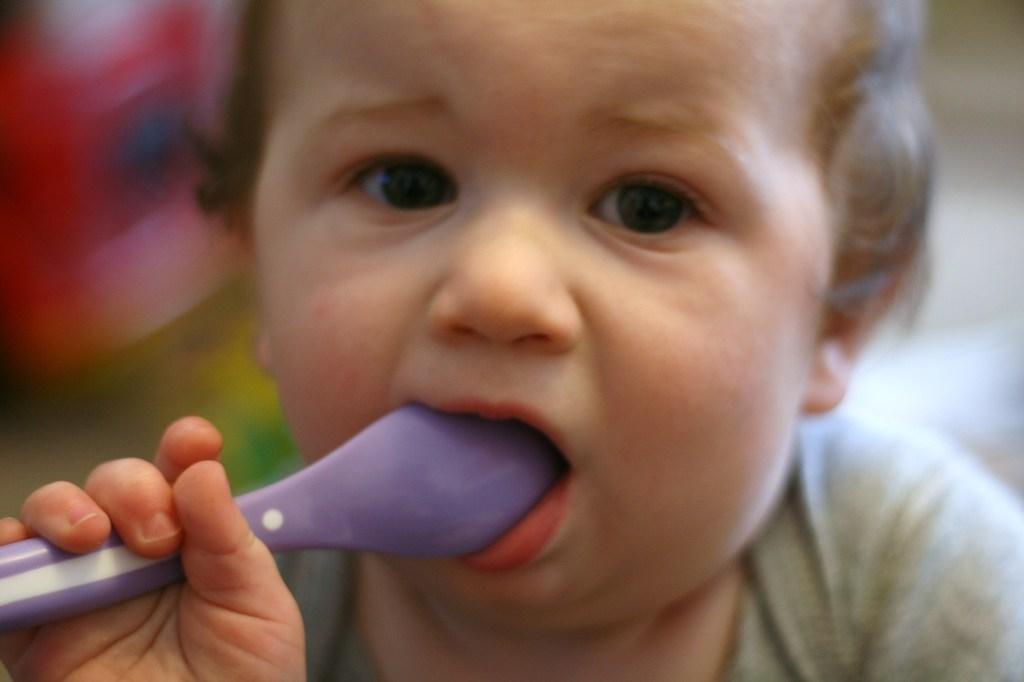Describe this image in one or two sentences. In this picture we can see a child holding a spoon and in the background it is blurry. 